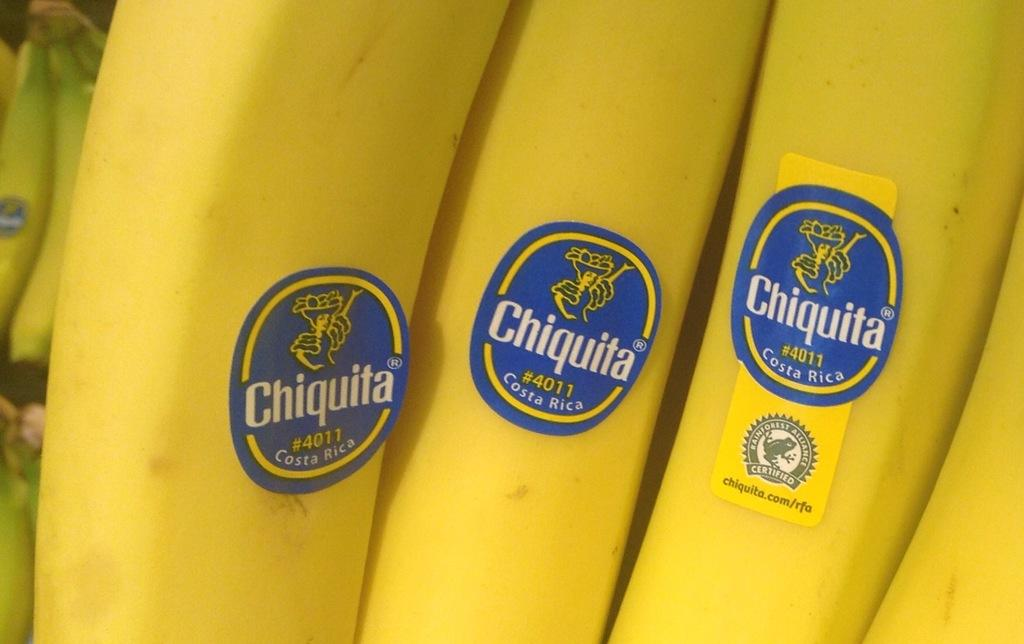What type of fruit is present in the image? There are bananas in the image. What additional feature can be observed on the bananas? The bananas have labels on them. What type of detail can be seen on the brass instruments in the image? There are no brass instruments present in the image; it only features bananas with labels. 